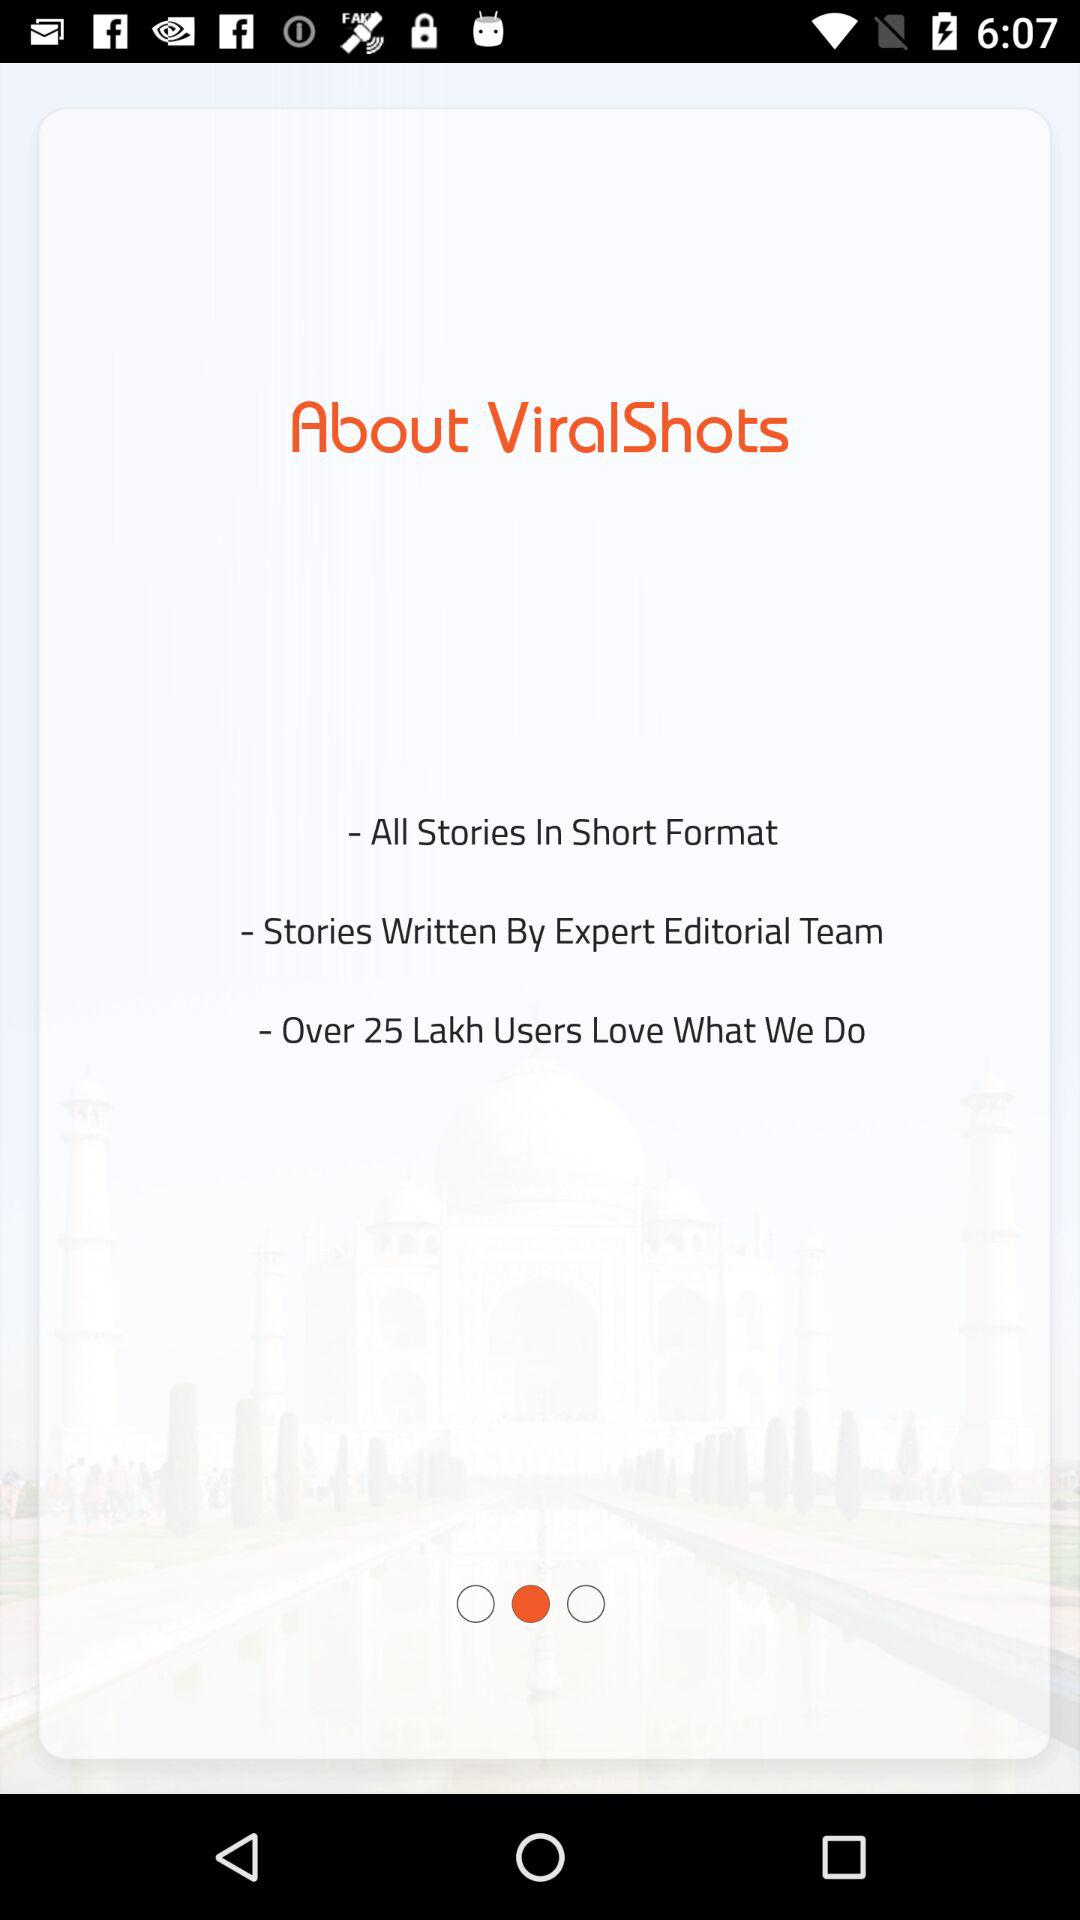Who wrote the stories? The stories are written by "Expert Editorial Team". 